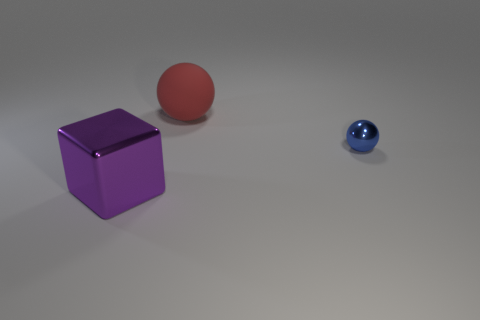Add 1 red shiny spheres. How many objects exist? 4 Subtract all balls. How many objects are left? 1 Add 1 red matte objects. How many red matte objects are left? 2 Add 3 big purple metal objects. How many big purple metal objects exist? 4 Subtract 0 red cubes. How many objects are left? 3 Subtract all purple blocks. Subtract all large red spheres. How many objects are left? 1 